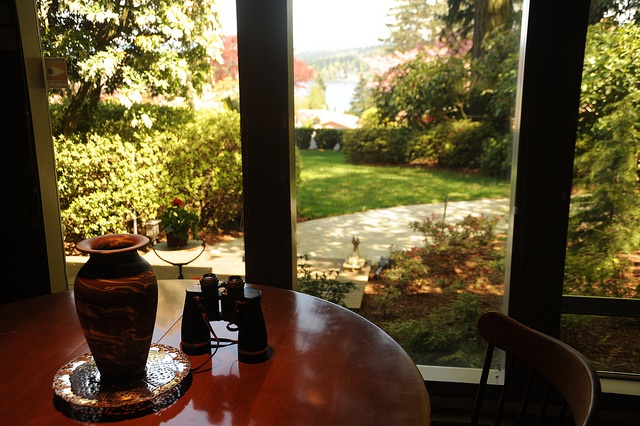Describe the objects in this image and their specific colors. I can see dining table in black, maroon, darkgray, and gray tones, vase in black, maroon, and brown tones, chair in black and gray tones, and potted plant in black, olive, and maroon tones in this image. 